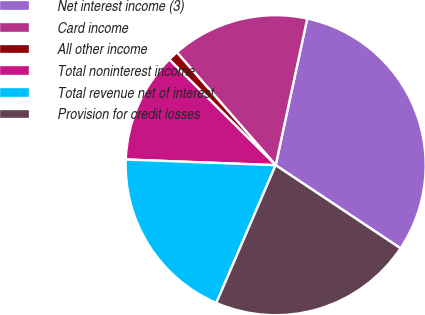<chart> <loc_0><loc_0><loc_500><loc_500><pie_chart><fcel>Net interest income (3)<fcel>Card income<fcel>All other income<fcel>Total noninterest income<fcel>Total revenue net of interest<fcel>Provision for credit losses<nl><fcel>30.97%<fcel>14.82%<fcel>1.11%<fcel>11.84%<fcel>19.13%<fcel>22.12%<nl></chart> 